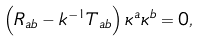<formula> <loc_0><loc_0><loc_500><loc_500>\left ( R _ { a b } - k ^ { - 1 } T _ { a b } \right ) \kappa ^ { a } \kappa ^ { b } = 0 ,</formula> 